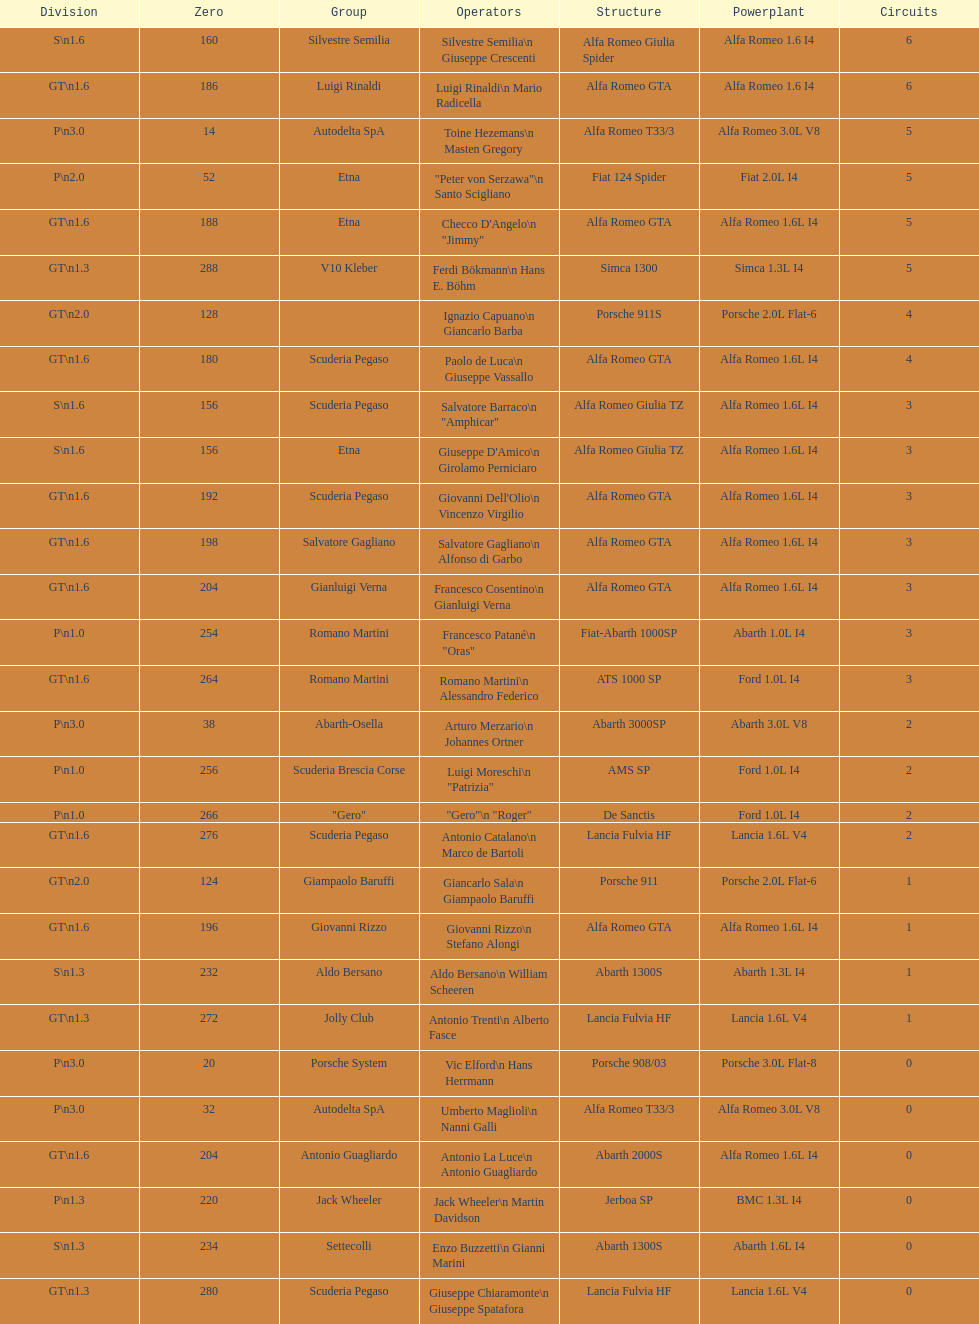How many drivers are from italy? 48. 